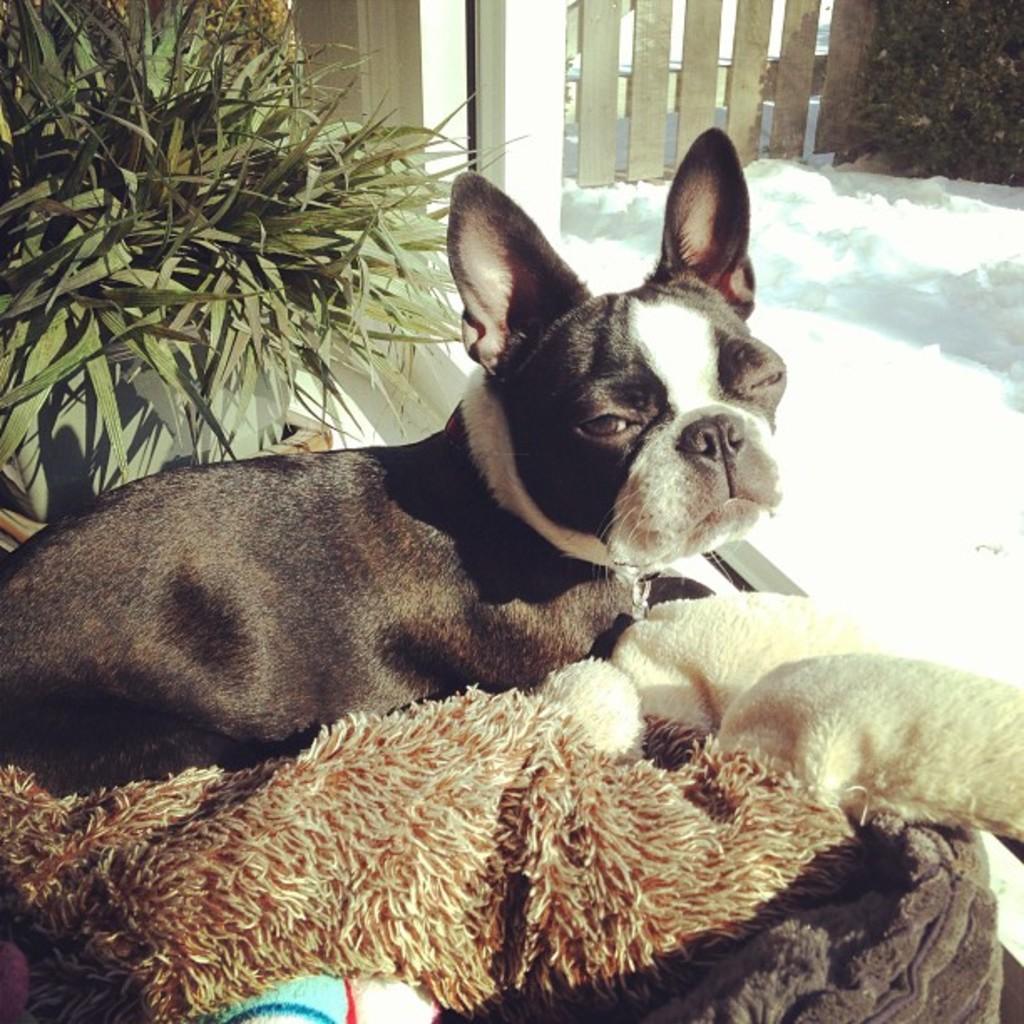How would you summarize this image in a sentence or two? In a given image I can see an animal, plant and fence. 